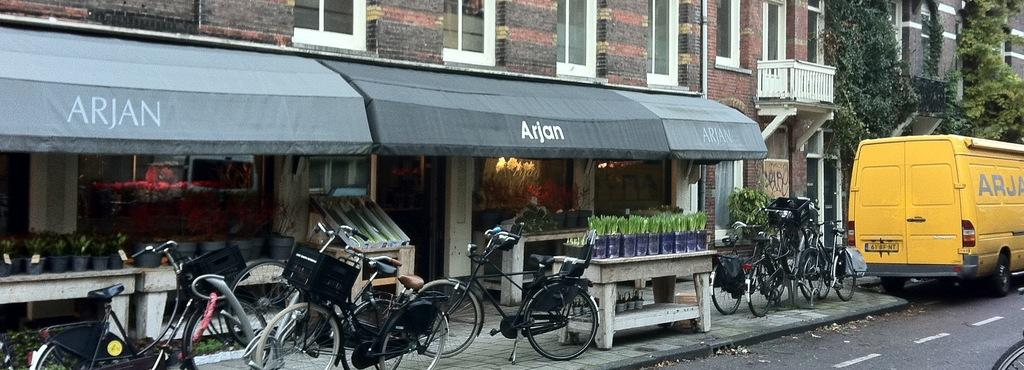What type of structure is visible in the image? There is a building in the image. What feature can be seen on the building? The building has windows. What mode of transportation is present in the image? There are bicycles and a vehicle in the image. What type of surface is visible in the image? There is a road in the image, with white lines on it. What additional feature can be seen in the image? There is a plant in the image. What path is visible for pedestrians in the image? There is a footpath in the image. What type of question is being asked in the image? There is no question being asked in the image; it is a visual representation of a scene. Can you see a crib in the image? There is no crib present in the image. Is there a baseball game happening in the image? There is no baseball game or any reference to baseball in the image. 